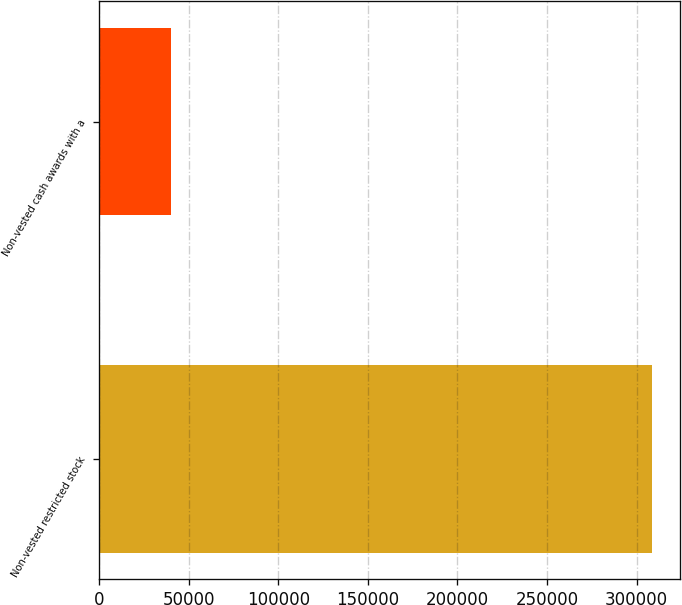Convert chart. <chart><loc_0><loc_0><loc_500><loc_500><bar_chart><fcel>Non-vested restricted stock<fcel>Non-vested cash awards with a<nl><fcel>308700<fcel>39850<nl></chart> 